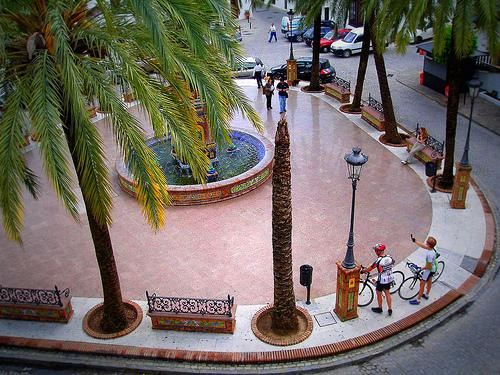Question: who are the people in the lower right corner of the picture?
Choices:
A. Walkers.
B. Runners.
C. Cyclists.
D. Acrobats.
Answer with the letter. Answer: C Question: what color are the trees in the picture?
Choices:
A. Orange.
B. Yellow.
C. Brown and green.
D. Red.
Answer with the letter. Answer: C Question: how many trees are seen in the picture?
Choices:
A. 4.
B. 3.
C. 6.
D. 2.
Answer with the letter. Answer: C Question: what color is the sidewalk?
Choices:
A. White.
B. Grey.
C. Silver.
D. Brown.
Answer with the letter. Answer: A Question: what is the weather like in the picture?
Choices:
A. Cloudy.
B. Clear.
C. Rainy.
D. Hailing.
Answer with the letter. Answer: B Question: who took the picture?
Choices:
A. A little girl.
B. A drone.
C. An automatic picture machine.
D. Photographer.
Answer with the letter. Answer: D 